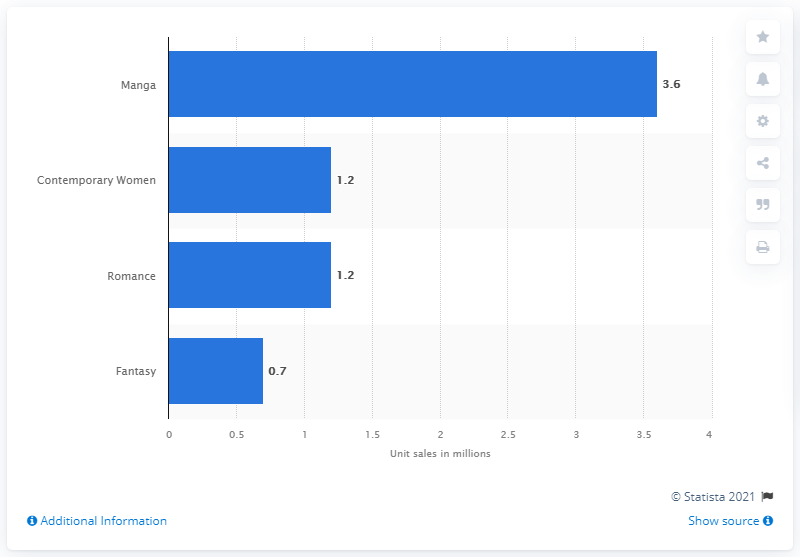Mention a couple of crucial points in this snapshot. Manga sales increased by 3.6% between the first quarter of 2020 and the first quarter of 2021. Contemporary women's fiction and romance novels experienced a growth of 1.2 units over the course of a year. 